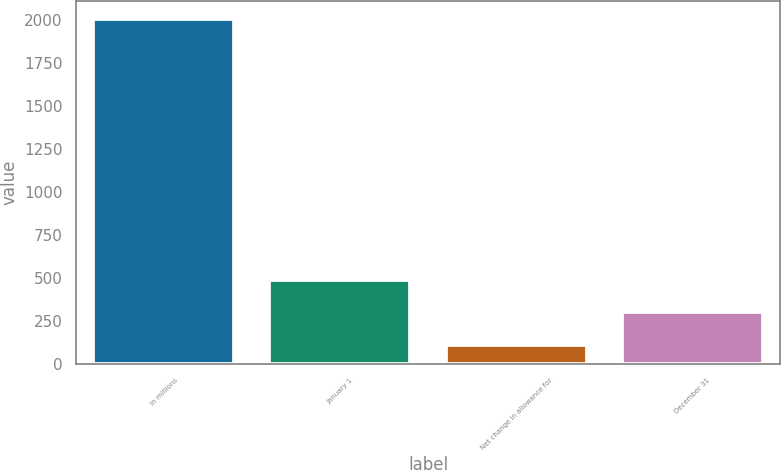<chart> <loc_0><loc_0><loc_500><loc_500><bar_chart><fcel>In millions<fcel>January 1<fcel>Net change in allowance for<fcel>December 31<nl><fcel>2010<fcel>488.4<fcel>108<fcel>298.2<nl></chart> 